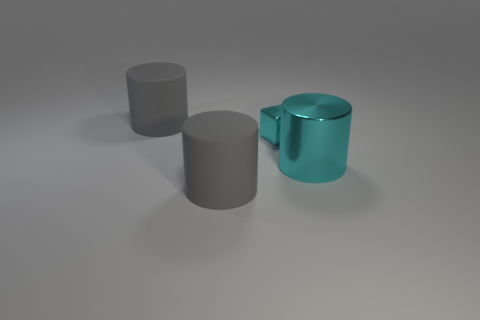Are there any matte objects of the same color as the big metal object?
Your answer should be compact. No. Is the big cyan object the same shape as the small cyan thing?
Offer a terse response. No. How many tiny objects are matte things or cyan blocks?
Ensure brevity in your answer.  1. The large thing that is the same material as the small cube is what color?
Offer a very short reply. Cyan. What number of tiny blocks have the same material as the large cyan object?
Your answer should be compact. 1. There is a thing behind the small cyan shiny block; is it the same size as the metal cube on the left side of the large metal thing?
Provide a succinct answer. No. What material is the thing on the right side of the cyan object behind the big cyan metallic object?
Provide a short and direct response. Metal. Are there fewer large gray matte things to the left of the cyan cylinder than large objects that are on the left side of the tiny cyan metal block?
Ensure brevity in your answer.  No. What material is the big object that is the same color as the block?
Keep it short and to the point. Metal. Is there any other thing that is the same shape as the small object?
Make the answer very short. No. 